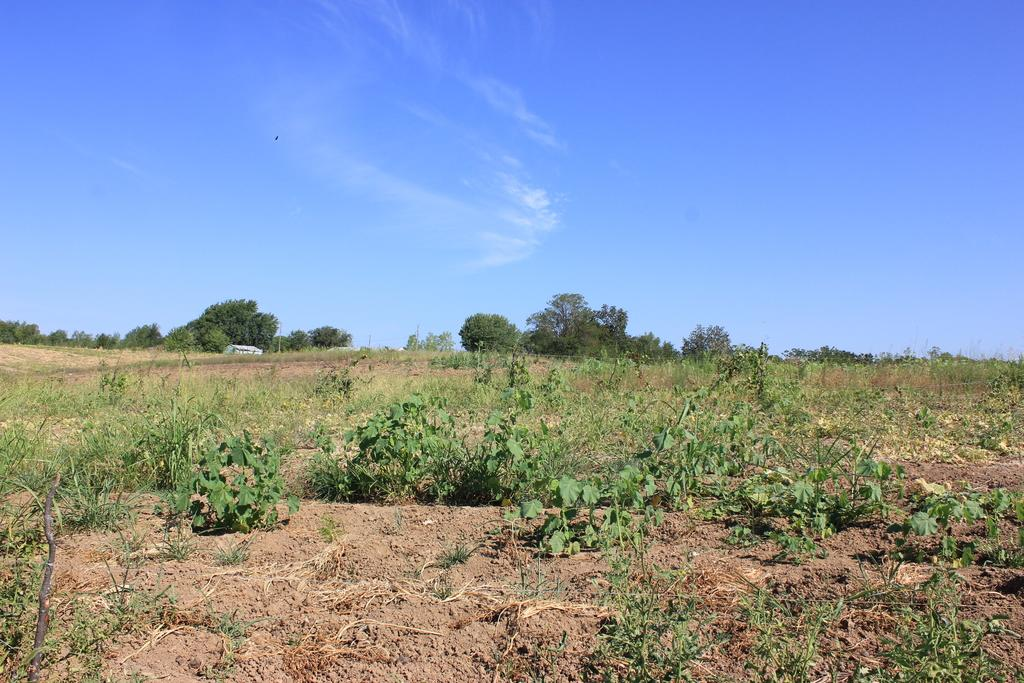What type of land surface is visible in the image? There is a land surface with grass and plants in the image. What can be seen in the distance on the land surface? Trees are visible in the distance. What is visible above the land surface in the image? The sky is visible in the image. What can be observed in the sky in the image? There are clouds in the sky. How many beds are visible in the image? There are no beds present in the image. What type of deer can be seen grazing in the grass in the image? There are no deer present in the image. 